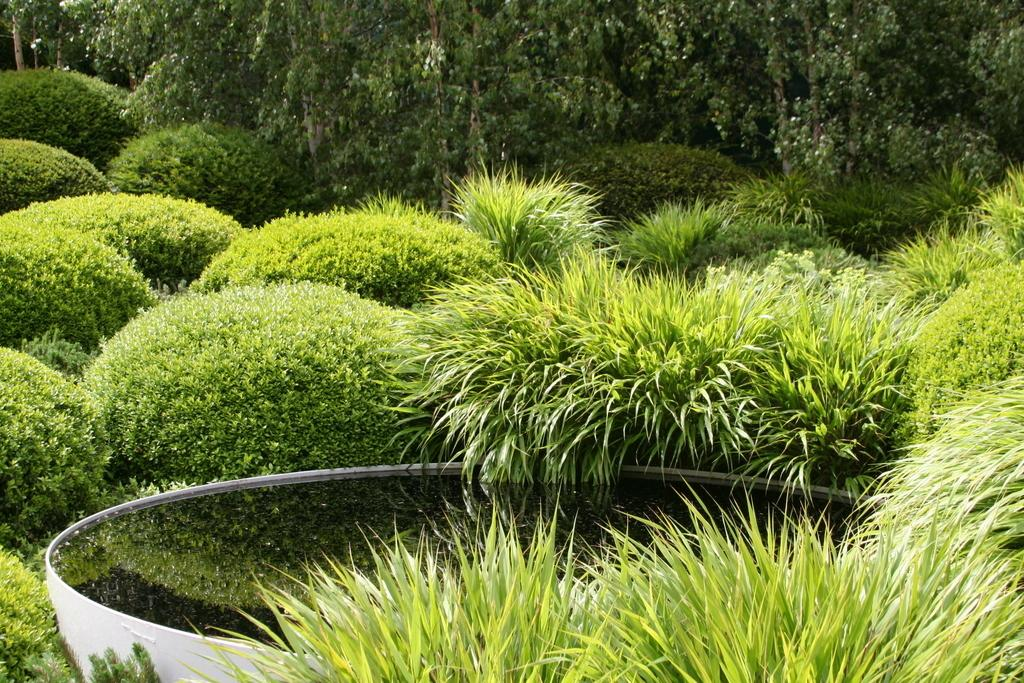What is the item in the image that contains water? There is an item containing water in the image, but the specific type of item is not mentioned. What can be seen behind the item containing water? There are bushes and trees behind the item containing water. How does the light affect the copy in the image? There is no mention of a copy or light in the image, so this question cannot be answered. 